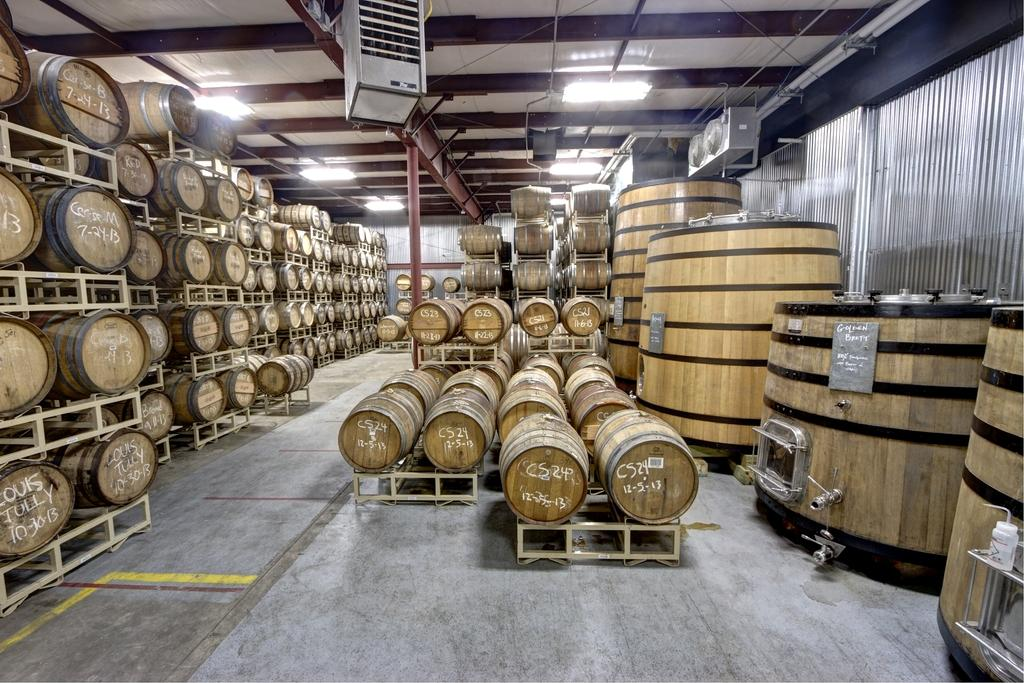What type of objects are present in large quantities in the image? There are many wooden barrels in the image. What surface can be seen beneath the barrels? There is a floor in the image. What type of barrier is visible in the image? There is a fence in the image. What vertical structure can be seen in the image? There is a pole in the image. What source of illumination is present in the image? There is a light in the image. How many sacks are being carried by the slave in the image? There is no slave or sacks present in the image; it only features wooden barrels, a floor, a fence, a pole, and a light. 